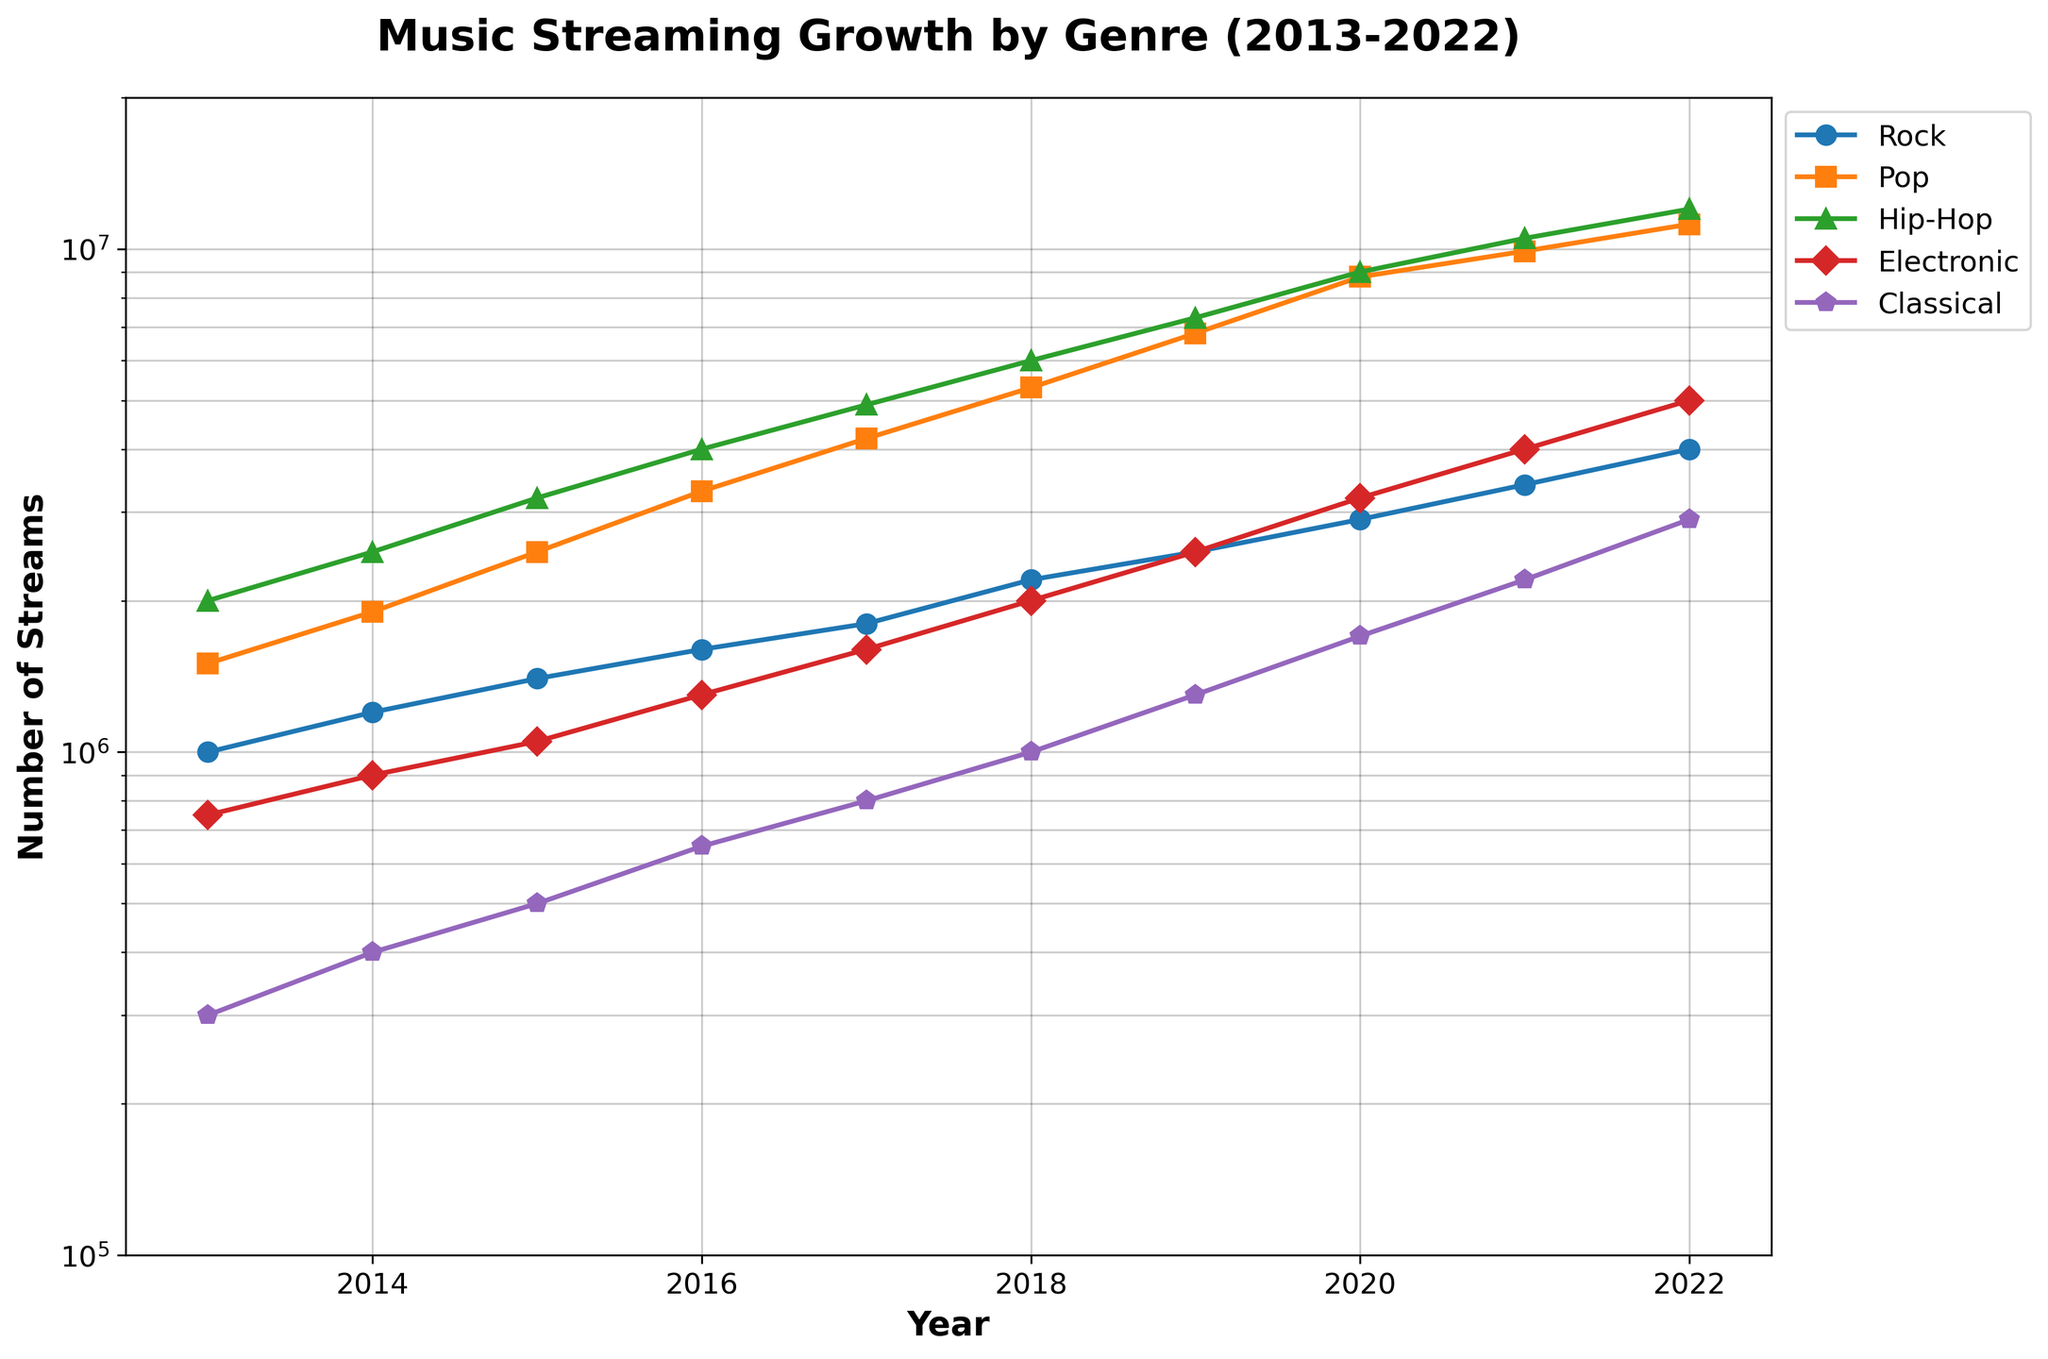What's the title of the figure? The title of the figure is written at the top of the plot and typically describes what the figure represents. In this case, it is "Music Streaming Growth by Genre (2013-2022)."
Answer: Music Streaming Growth by Genre (2013-2022) What is the scale of the y-axis? The scale of the y-axis is indicated by the labels on the axis and the fact that it increases exponentially. This means it is in a logarithmic scale (log scale).
Answer: Logarithmic How many genres are represented in the plot? There are different colored lines, each representing a genre, as indicated by the legend on the right side of the plot. Counting these lines gives us five genres.
Answer: 5 What is the color representing Rock among the lines? By examining the legend, we find that the line representing Rock is marked in blue.
Answer: Blue In which year did Rock first surpass 2 million streams? By observing the blue line (Rock) and following it along the x-axis, Rock surpassed 2 million streams in 2018.
Answer: 2018 What's the difference in the number of streams between Rock and Pop in the year 2022? In 2022, the number of streams for Rock is 4,000,000, and for Pop, it is 11,200,000. The difference is 11,200,000 - 4,000,000.
Answer: 7,200,000 Which genre had the most growth in streaming numbers from 2013 to 2022? By comparing the endpoints of all the genre lines from 2013 to 2022, Hip-Hop shows the highest increase, from 2,000,000 in 2013 to 12,000,000 in 2022.
Answer: Hip-Hop What is the overall trend for all genres from 2013 to 2022? Every line representing different genres shows an upward trend, indicating that the streaming numbers for all genres are increasing.
Answer: Increasing Which two genres had roughly similar stream numbers in 2017? By closely observing the points in 2017, Rock and Electronic had stream numbers that are close to each other: Rock (1,800,000) and Electronic (1,600,000).
Answer: Rock and Electronic Between which consecutive years did Classical see its most significant relative increase in streams? By looking at the green line (Classical) and comparing the vertical distance between data points, the largest jump occurs between 2020 and 2021 when it goes from 1,700,000 to 2,200,000 streams.
Answer: 2020 and 2021 